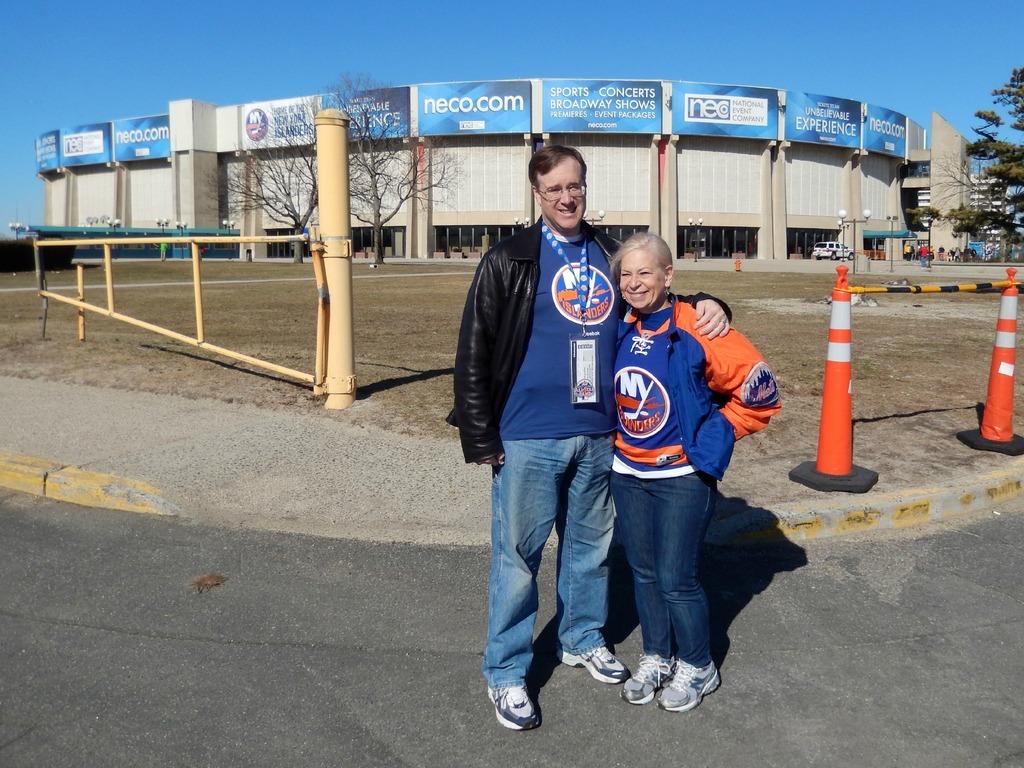Is neco.com a sponsor of that building?
Your answer should be compact. Yes. What team does their shirts say?
Provide a short and direct response. Ny islanders. 